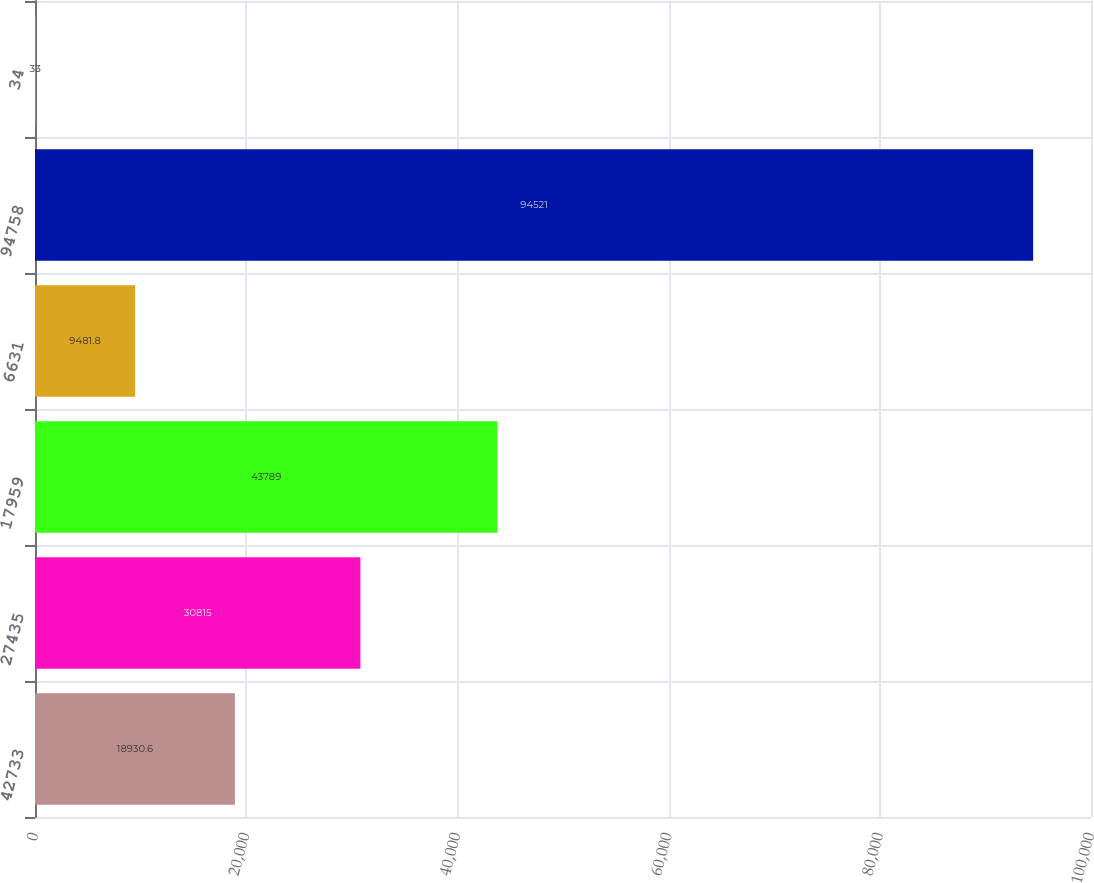Convert chart. <chart><loc_0><loc_0><loc_500><loc_500><bar_chart><fcel>42733<fcel>27435<fcel>17959<fcel>6631<fcel>94758<fcel>34<nl><fcel>18930.6<fcel>30815<fcel>43789<fcel>9481.8<fcel>94521<fcel>33<nl></chart> 